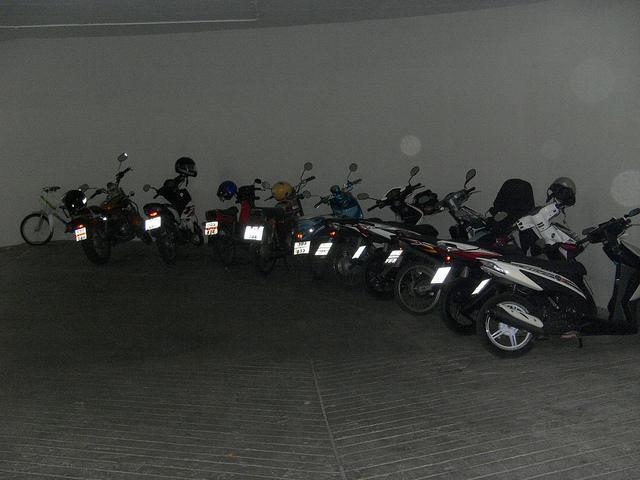How many motorcycles are there?
Give a very brief answer. 10. 